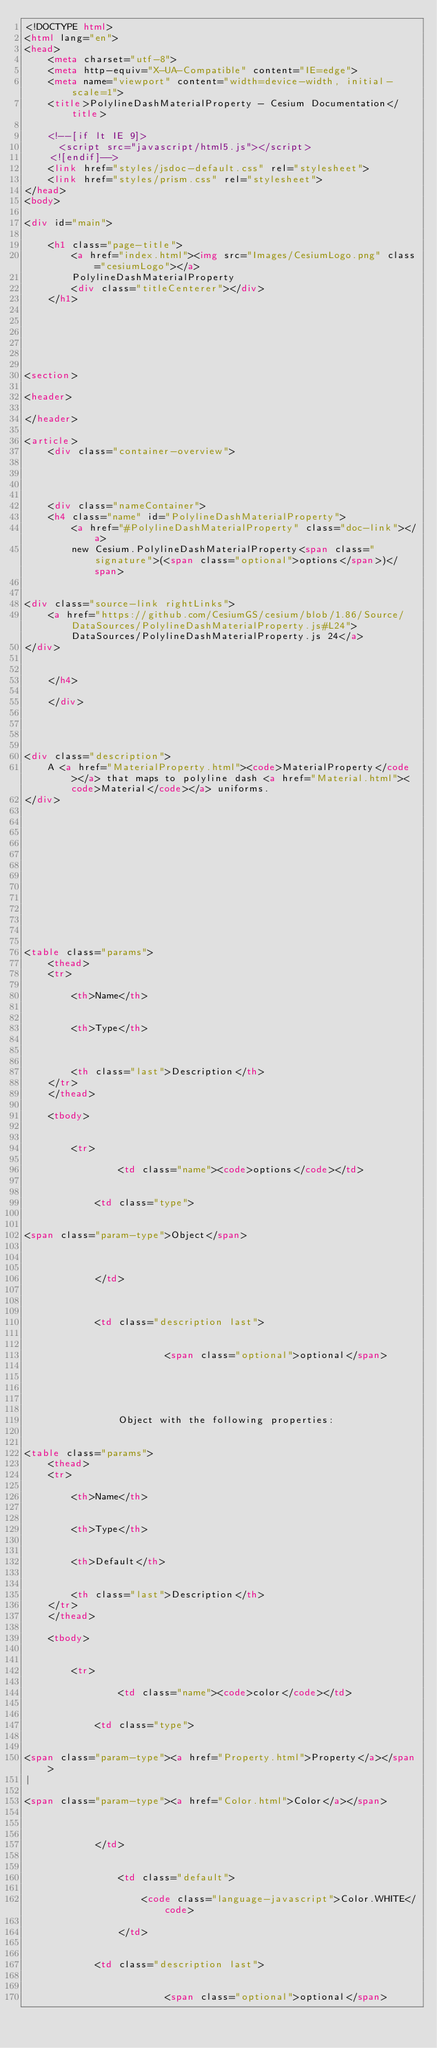Convert code to text. <code><loc_0><loc_0><loc_500><loc_500><_HTML_><!DOCTYPE html>
<html lang="en">
<head>
    <meta charset="utf-8">
    <meta http-equiv="X-UA-Compatible" content="IE=edge">
    <meta name="viewport" content="width=device-width, initial-scale=1">
    <title>PolylineDashMaterialProperty - Cesium Documentation</title>

    <!--[if lt IE 9]>
      <script src="javascript/html5.js"></script>
    <![endif]-->
    <link href="styles/jsdoc-default.css" rel="stylesheet">
    <link href="styles/prism.css" rel="stylesheet">
</head>
<body>

<div id="main">

    <h1 class="page-title">
        <a href="index.html"><img src="Images/CesiumLogo.png" class="cesiumLogo"></a>
        PolylineDashMaterialProperty
        <div class="titleCenterer"></div>
    </h1>

    




<section>

<header>
    
</header>

<article>
    <div class="container-overview">
    

    
        
    <div class="nameContainer">
    <h4 class="name" id="PolylineDashMaterialProperty">
        <a href="#PolylineDashMaterialProperty" class="doc-link"></a>
        new Cesium.PolylineDashMaterialProperty<span class="signature">(<span class="optional">options</span>)</span>
        

<div class="source-link rightLinks">
    <a href="https://github.com/CesiumGS/cesium/blob/1.86/Source/DataSources/PolylineDashMaterialProperty.js#L24">DataSources/PolylineDashMaterialProperty.js 24</a>
</div>


    </h4>

    </div>

    


<div class="description">
    A <a href="MaterialProperty.html"><code>MaterialProperty</code></a> that maps to polyline dash <a href="Material.html"><code>Material</code></a> uniforms.
</div>











    

<table class="params">
    <thead>
    <tr>
        
        <th>Name</th>
        

        <th>Type</th>

        

        <th class="last">Description</th>
    </tr>
    </thead>

    <tbody>
    

        <tr>
            
                <td class="name"><code>options</code></td>
            

            <td class="type">
            
                
<span class="param-type">Object</span>


            
            </td>

            

            <td class="description last">
            
                
                        <span class="optional">optional</span>
                
                

                
            
                Object with the following properties:
                

<table class="params">
    <thead>
    <tr>
        
        <th>Name</th>
        

        <th>Type</th>

        
        <th>Default</th>
        

        <th class="last">Description</th>
    </tr>
    </thead>

    <tbody>
    

        <tr>
            
                <td class="name"><code>color</code></td>
            

            <td class="type">
            
                
<span class="param-type"><a href="Property.html">Property</a></span>
|

<span class="param-type"><a href="Color.html">Color</a></span>


            
            </td>

            
                <td class="default">
                
                    <code class="language-javascript">Color.WHITE</code>
                
                </td>
            

            <td class="description last">
            
                
                        <span class="optional">optional</span>
                
                
</code> 